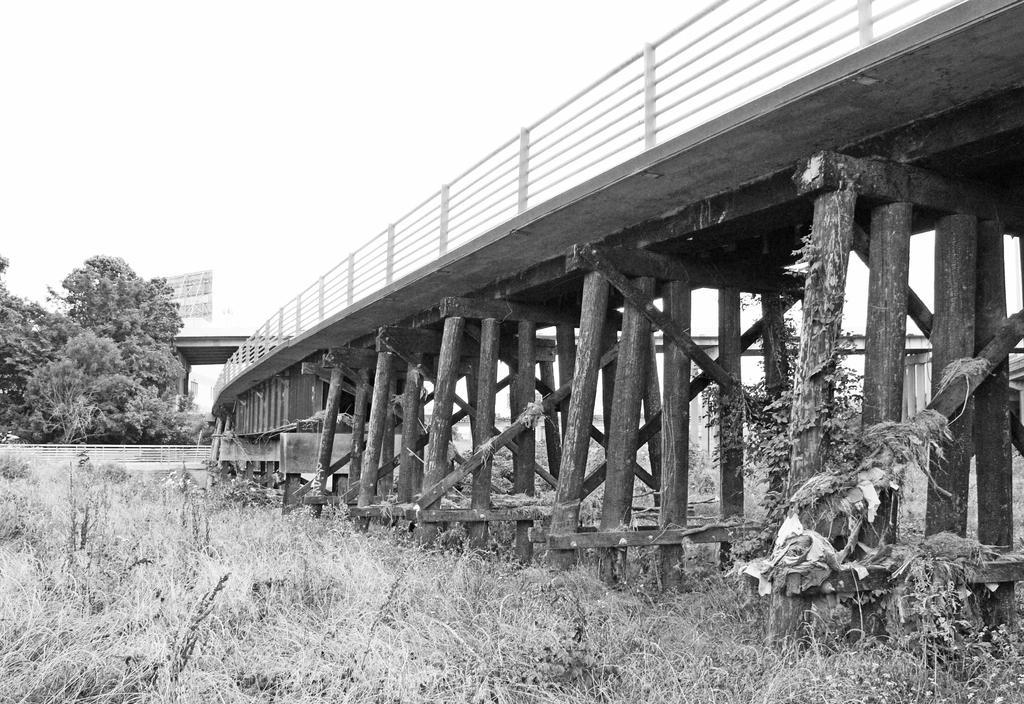In one or two sentences, can you explain what this image depicts? In this picture we are looking at one bridge and this bridge look like old and all this are wood from here left side to till right side all this are wood. And this button one are grass. 